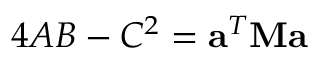Convert formula to latex. <formula><loc_0><loc_0><loc_500><loc_500>4 A B - C ^ { 2 } = a ^ { T } M a</formula> 